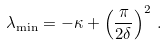<formula> <loc_0><loc_0><loc_500><loc_500>\lambda _ { \min } = - \kappa + \left ( \frac { \pi } { 2 \delta } \right ) ^ { 2 } \, .</formula> 